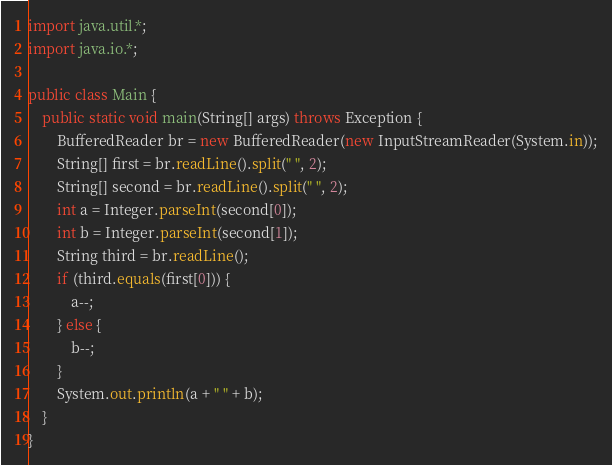Convert code to text. <code><loc_0><loc_0><loc_500><loc_500><_Java_>import java.util.*;
import java.io.*;

public class Main {
    public static void main(String[] args) throws Exception {
        BufferedReader br = new BufferedReader(new InputStreamReader(System.in));
        String[] first = br.readLine().split(" ", 2);
        String[] second = br.readLine().split(" ", 2);
        int a = Integer.parseInt(second[0]);
        int b = Integer.parseInt(second[1]);
        String third = br.readLine();
        if (third.equals(first[0])) {
            a--;
        } else {
            b--;
        }
        System.out.println(a + " " + b);
    }
}</code> 